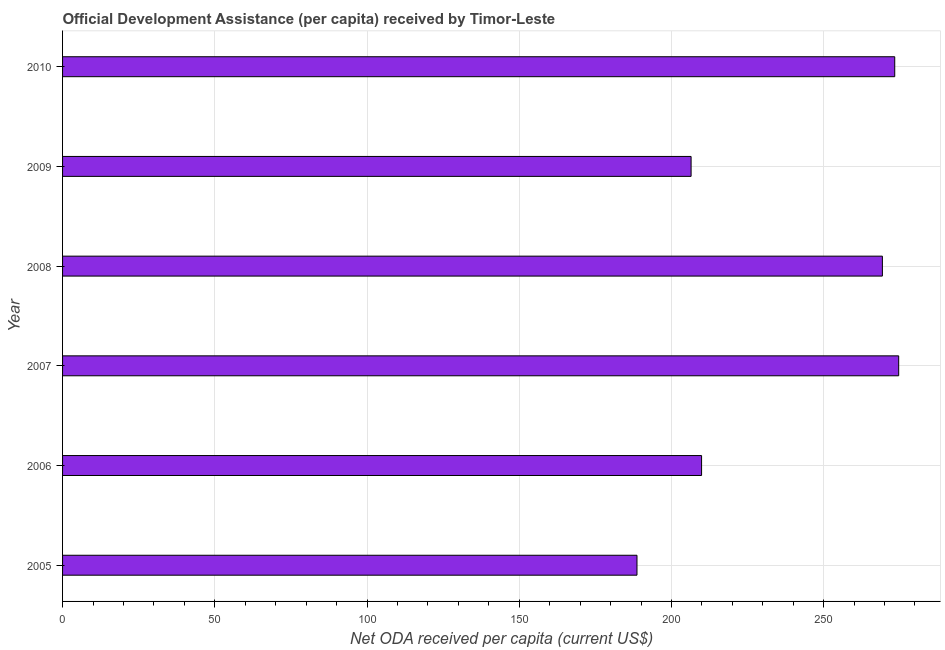Does the graph contain any zero values?
Provide a succinct answer. No. Does the graph contain grids?
Provide a short and direct response. Yes. What is the title of the graph?
Make the answer very short. Official Development Assistance (per capita) received by Timor-Leste. What is the label or title of the X-axis?
Your answer should be very brief. Net ODA received per capita (current US$). What is the label or title of the Y-axis?
Provide a short and direct response. Year. What is the net oda received per capita in 2007?
Offer a very short reply. 274.65. Across all years, what is the maximum net oda received per capita?
Your answer should be very brief. 274.65. Across all years, what is the minimum net oda received per capita?
Your answer should be very brief. 188.68. In which year was the net oda received per capita maximum?
Provide a short and direct response. 2007. What is the sum of the net oda received per capita?
Make the answer very short. 1422.32. What is the difference between the net oda received per capita in 2007 and 2009?
Provide a short and direct response. 68.19. What is the average net oda received per capita per year?
Give a very brief answer. 237.05. What is the median net oda received per capita?
Give a very brief answer. 239.6. In how many years, is the net oda received per capita greater than 50 US$?
Make the answer very short. 6. What is the difference between the highest and the second highest net oda received per capita?
Provide a succinct answer. 1.3. What is the difference between the highest and the lowest net oda received per capita?
Provide a short and direct response. 85.96. In how many years, is the net oda received per capita greater than the average net oda received per capita taken over all years?
Make the answer very short. 3. How many years are there in the graph?
Provide a succinct answer. 6. What is the difference between two consecutive major ticks on the X-axis?
Offer a very short reply. 50. Are the values on the major ticks of X-axis written in scientific E-notation?
Provide a succinct answer. No. What is the Net ODA received per capita (current US$) of 2005?
Give a very brief answer. 188.68. What is the Net ODA received per capita (current US$) in 2006?
Provide a short and direct response. 209.9. What is the Net ODA received per capita (current US$) in 2007?
Your answer should be compact. 274.65. What is the Net ODA received per capita (current US$) in 2008?
Offer a terse response. 269.29. What is the Net ODA received per capita (current US$) in 2009?
Keep it short and to the point. 206.45. What is the Net ODA received per capita (current US$) of 2010?
Your answer should be very brief. 273.35. What is the difference between the Net ODA received per capita (current US$) in 2005 and 2006?
Provide a succinct answer. -21.21. What is the difference between the Net ODA received per capita (current US$) in 2005 and 2007?
Provide a succinct answer. -85.96. What is the difference between the Net ODA received per capita (current US$) in 2005 and 2008?
Offer a very short reply. -80.61. What is the difference between the Net ODA received per capita (current US$) in 2005 and 2009?
Your answer should be compact. -17.77. What is the difference between the Net ODA received per capita (current US$) in 2005 and 2010?
Give a very brief answer. -84.66. What is the difference between the Net ODA received per capita (current US$) in 2006 and 2007?
Ensure brevity in your answer.  -64.75. What is the difference between the Net ODA received per capita (current US$) in 2006 and 2008?
Offer a terse response. -59.39. What is the difference between the Net ODA received per capita (current US$) in 2006 and 2009?
Offer a terse response. 3.44. What is the difference between the Net ODA received per capita (current US$) in 2006 and 2010?
Provide a short and direct response. -63.45. What is the difference between the Net ODA received per capita (current US$) in 2007 and 2008?
Make the answer very short. 5.35. What is the difference between the Net ODA received per capita (current US$) in 2007 and 2009?
Provide a succinct answer. 68.19. What is the difference between the Net ODA received per capita (current US$) in 2007 and 2010?
Offer a terse response. 1.3. What is the difference between the Net ODA received per capita (current US$) in 2008 and 2009?
Offer a terse response. 62.84. What is the difference between the Net ODA received per capita (current US$) in 2008 and 2010?
Your response must be concise. -4.06. What is the difference between the Net ODA received per capita (current US$) in 2009 and 2010?
Provide a short and direct response. -66.89. What is the ratio of the Net ODA received per capita (current US$) in 2005 to that in 2006?
Your response must be concise. 0.9. What is the ratio of the Net ODA received per capita (current US$) in 2005 to that in 2007?
Your answer should be very brief. 0.69. What is the ratio of the Net ODA received per capita (current US$) in 2005 to that in 2008?
Ensure brevity in your answer.  0.7. What is the ratio of the Net ODA received per capita (current US$) in 2005 to that in 2009?
Offer a terse response. 0.91. What is the ratio of the Net ODA received per capita (current US$) in 2005 to that in 2010?
Provide a short and direct response. 0.69. What is the ratio of the Net ODA received per capita (current US$) in 2006 to that in 2007?
Your answer should be compact. 0.76. What is the ratio of the Net ODA received per capita (current US$) in 2006 to that in 2008?
Your response must be concise. 0.78. What is the ratio of the Net ODA received per capita (current US$) in 2006 to that in 2010?
Give a very brief answer. 0.77. What is the ratio of the Net ODA received per capita (current US$) in 2007 to that in 2009?
Give a very brief answer. 1.33. What is the ratio of the Net ODA received per capita (current US$) in 2008 to that in 2009?
Your answer should be compact. 1.3. What is the ratio of the Net ODA received per capita (current US$) in 2008 to that in 2010?
Your response must be concise. 0.98. What is the ratio of the Net ODA received per capita (current US$) in 2009 to that in 2010?
Offer a very short reply. 0.76. 